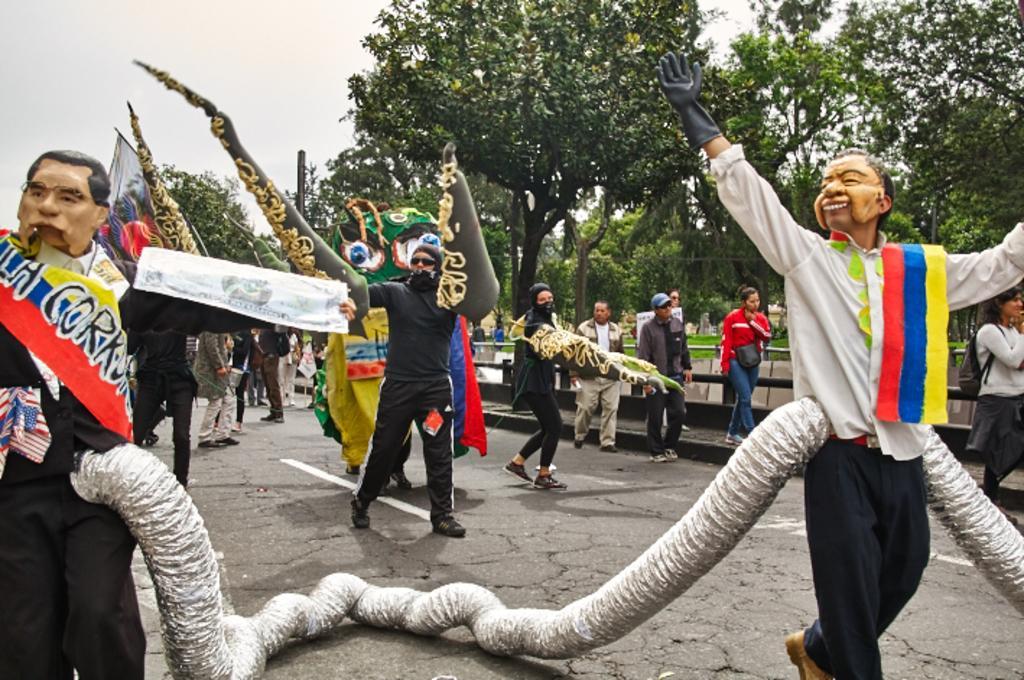How would you summarize this image in a sentence or two? In this image we can see people wearing costumes and performing on the road. In the background there are people walking on the road, trees, creeper plants and sky. 